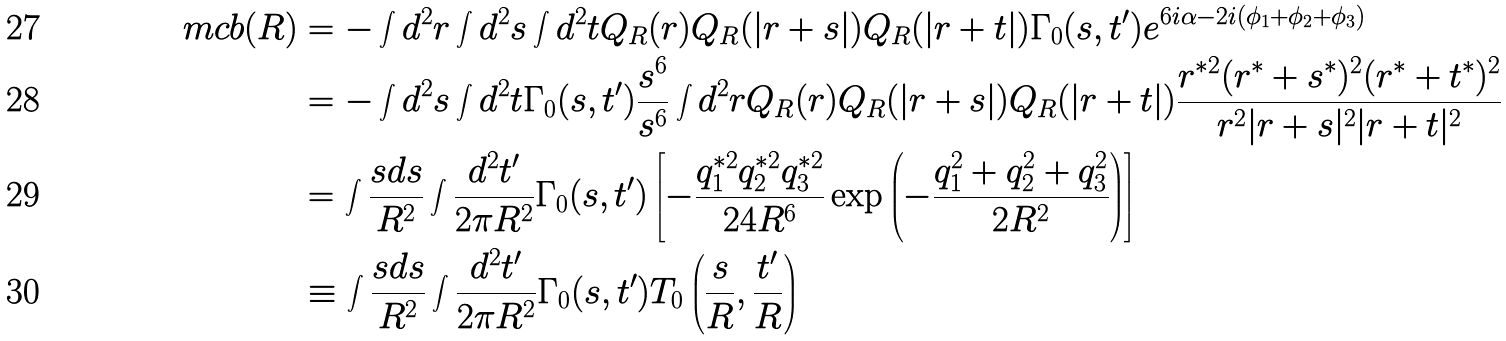Convert formula to latex. <formula><loc_0><loc_0><loc_500><loc_500>\ m c b ( R ) & = - \int d ^ { 2 } r \int d ^ { 2 } s \int d ^ { 2 } t Q _ { R } ( r ) Q _ { R } ( | r + s | ) Q _ { R } ( | r + t | ) \Gamma _ { 0 } ( s , t ^ { \prime } ) e ^ { 6 i \alpha - 2 i ( \phi _ { 1 } + \phi _ { 2 } + \phi _ { 3 } ) } \\ & = - \int d ^ { 2 } s \int d ^ { 2 } t \Gamma _ { 0 } ( s , t ^ { \prime } ) \frac { s ^ { 6 } } { s ^ { 6 } } \int d ^ { 2 } r Q _ { R } ( r ) Q _ { R } ( | r + s | ) Q _ { R } ( | r + t | ) \frac { r ^ { * 2 } ( r ^ { * } + s ^ { * } ) ^ { 2 } ( r ^ { * } + t ^ { * } ) ^ { 2 } } { r ^ { 2 } | r + s | ^ { 2 } | r + t | ^ { 2 } } \\ & = \int \frac { s d s } { R ^ { 2 } } \int \frac { d ^ { 2 } t ^ { \prime } } { 2 \pi R ^ { 2 } } \Gamma _ { 0 } ( s , t ^ { \prime } ) \left [ - \frac { q _ { 1 } ^ { * 2 } q _ { 2 } ^ { * 2 } q _ { 3 } ^ { * 2 } } { 2 4 R ^ { 6 } } \exp \left ( - \frac { q _ { 1 } ^ { 2 } + q _ { 2 } ^ { 2 } + q _ { 3 } ^ { 2 } } { 2 R ^ { 2 } } \right ) \right ] \\ & \equiv \int \frac { s d s } { R ^ { 2 } } \int \frac { d ^ { 2 } t ^ { \prime } } { 2 \pi R ^ { 2 } } \Gamma _ { 0 } ( s , t ^ { \prime } ) T _ { 0 } \left ( \frac { s } { R } , \frac { t ^ { \prime } } { R } \right )</formula> 